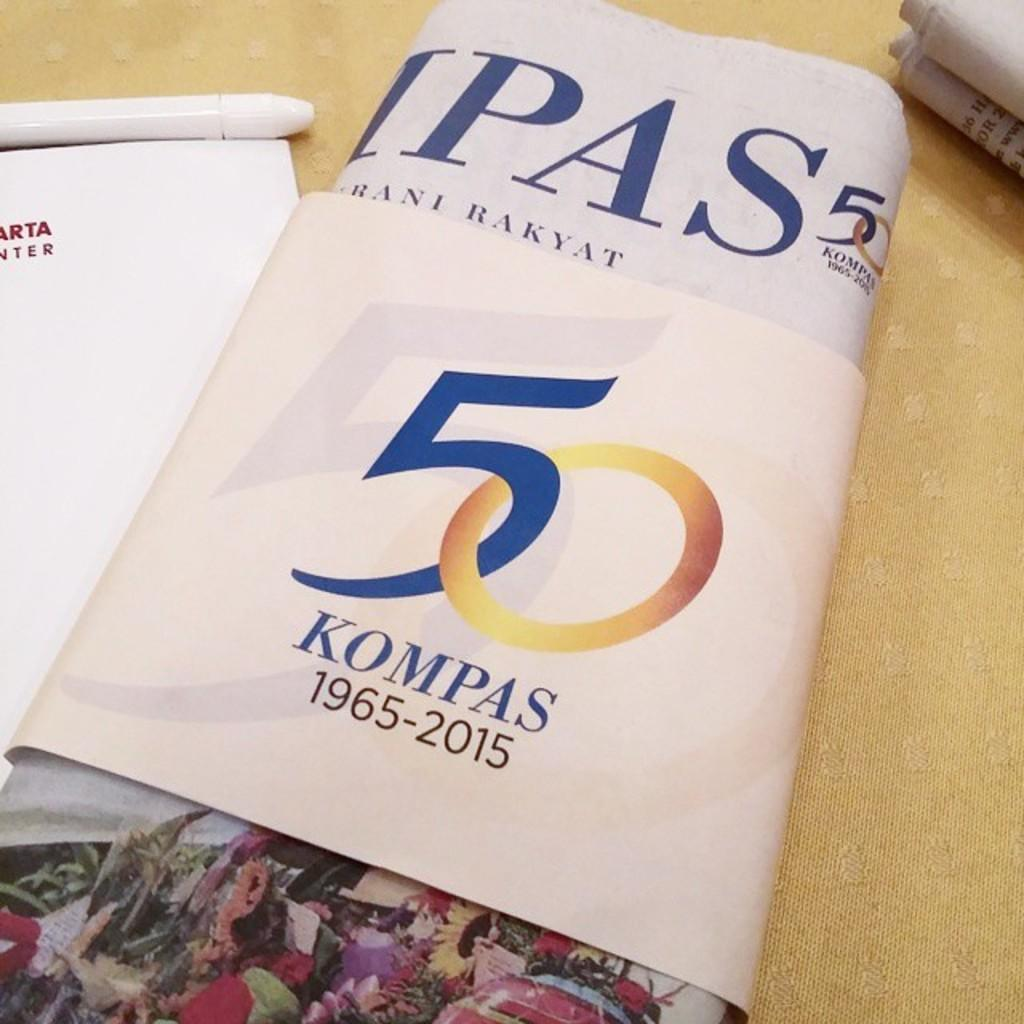<image>
Render a clear and concise summary of the photo. the name Kompas that has 1965 on it 